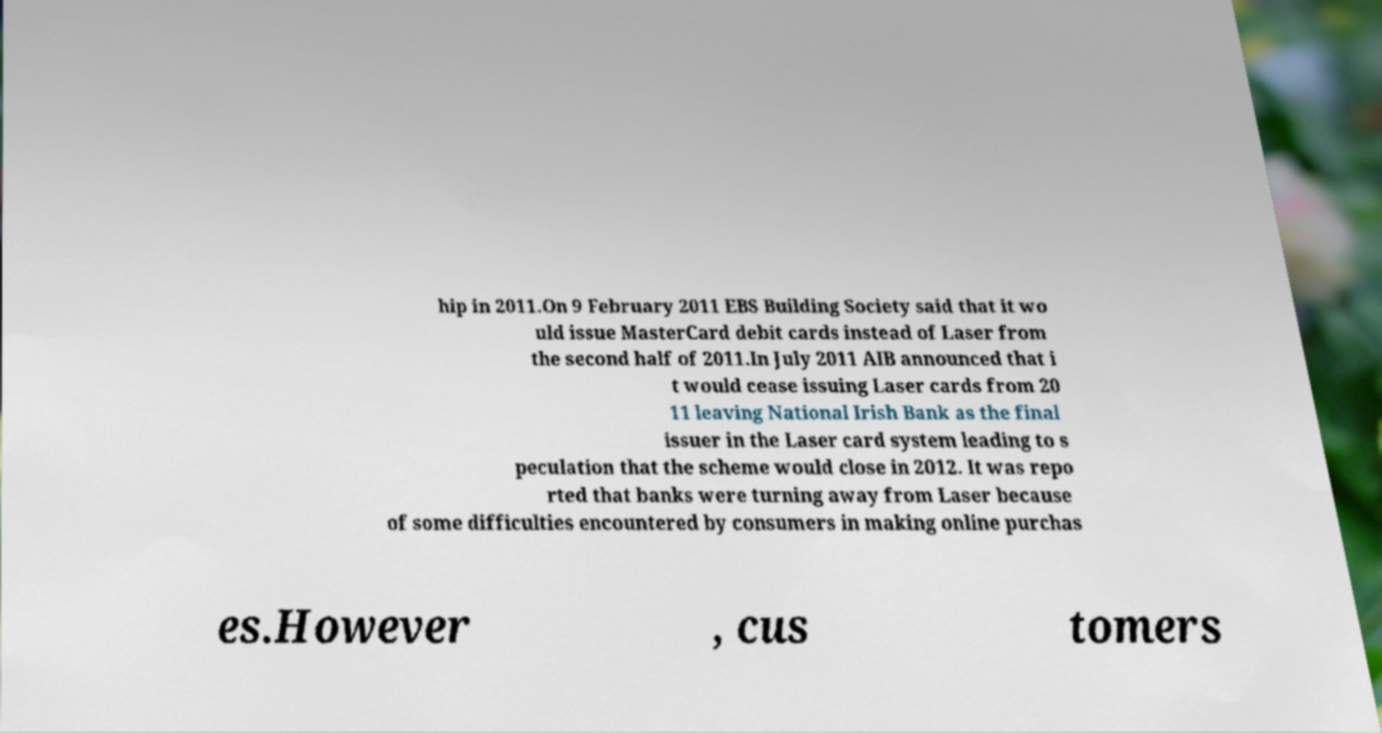Could you extract and type out the text from this image? hip in 2011.On 9 February 2011 EBS Building Society said that it wo uld issue MasterCard debit cards instead of Laser from the second half of 2011.In July 2011 AIB announced that i t would cease issuing Laser cards from 20 11 leaving National Irish Bank as the final issuer in the Laser card system leading to s peculation that the scheme would close in 2012. It was repo rted that banks were turning away from Laser because of some difficulties encountered by consumers in making online purchas es.However , cus tomers 